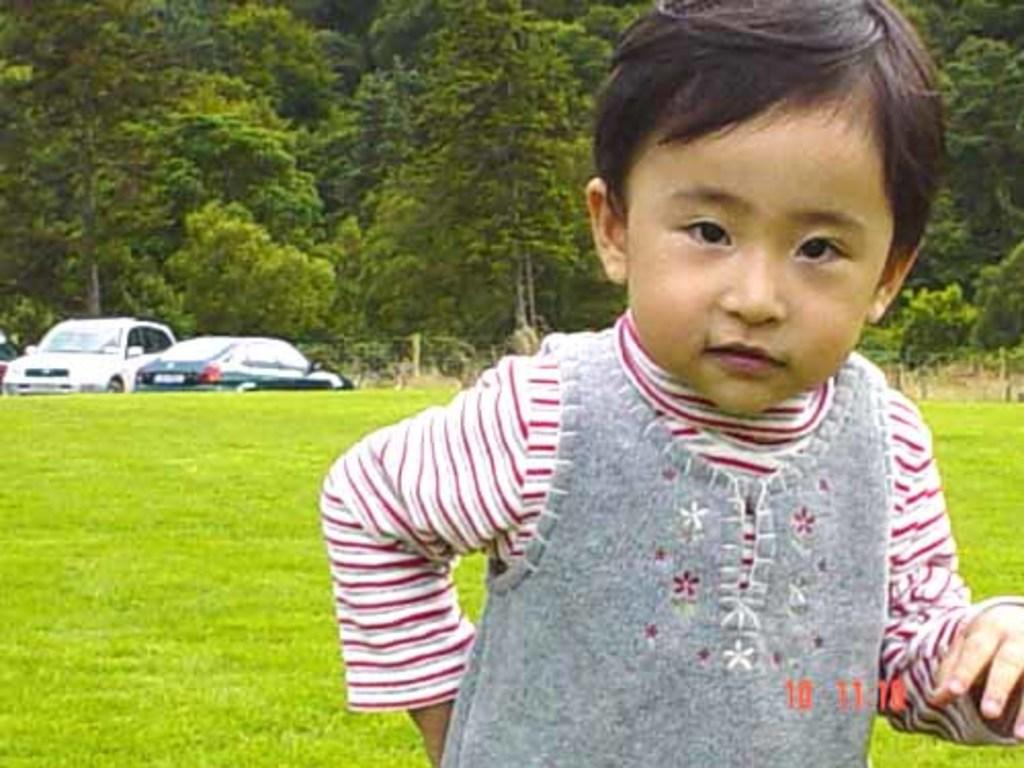Who is the main subject in the image? There is a boy in the image. What type of terrain is visible in the image? Grass is visible on the ground. What can be seen in the background of the image? There are vehicles and trees present in the background of the image. What type of flame can be seen coming from the boy's hand in the image? There is no flame present in the image; the boy's hand is not depicted as producing any flame. 